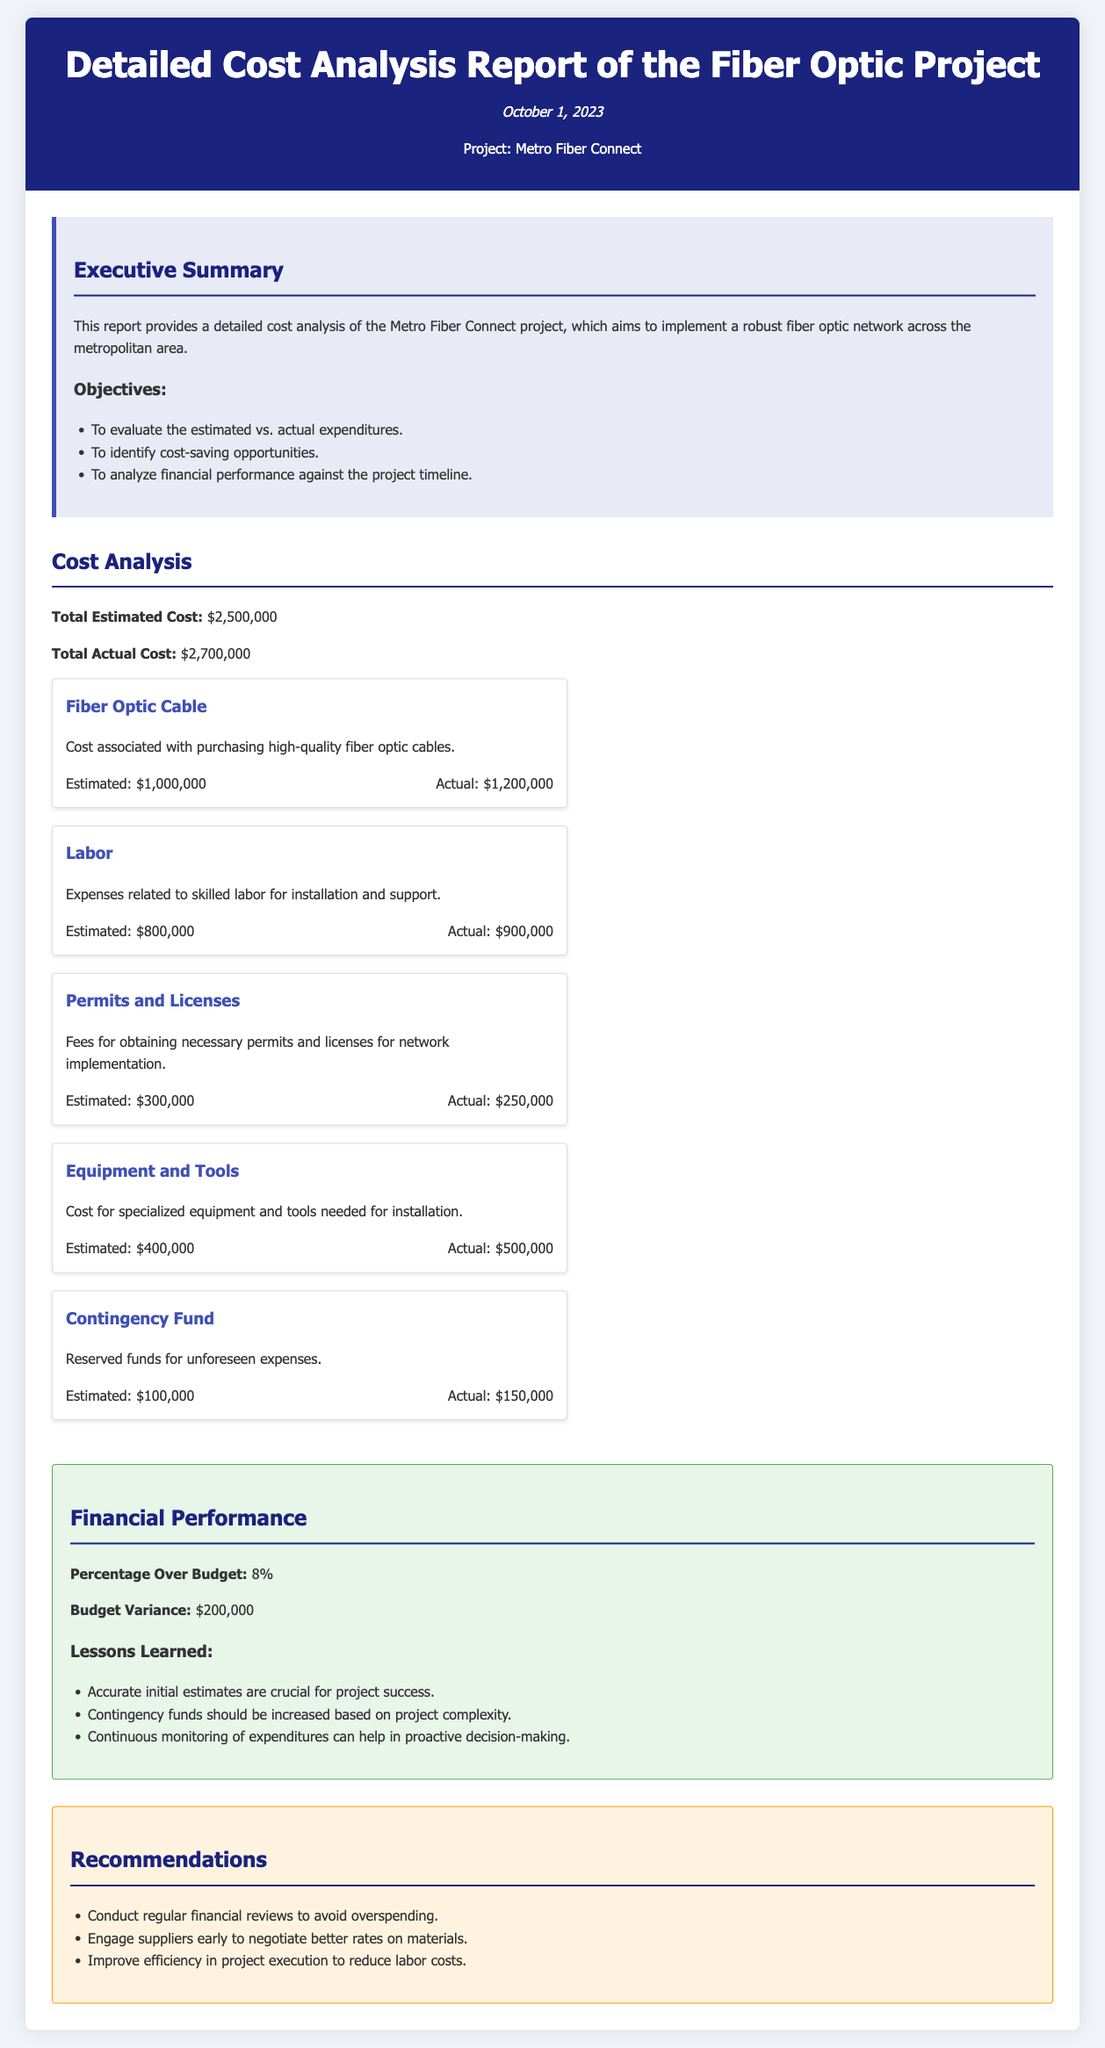What is the total estimated cost? The total estimated cost is provided in the document, which is $2,500,000.
Answer: $2,500,000 What is the total actual cost? The total actual cost is mentioned in the report, which is $2,700,000.
Answer: $2,700,000 What is the percentage over budget? The percentage over budget is calculated based on actual costs exceeding estimated costs, which is 8%.
Answer: 8% How much was spent on labor? The actual expenditure on labor is detailed in the cost breakdown, which is $900,000.
Answer: $900,000 What is the estimated cost for permits and licenses? The estimated cost for permits and licenses is listed in the cost breakdown as $300,000.
Answer: $300,000 Which category had the highest actual expenditure? By comparing the actual costs in the cost breakdown, Fiber Optic Cable had the highest actual expenditure.
Answer: Fiber Optic Cable What are the lessons learned mentioned in the report? The lessons learned include three specific points explained in the document.
Answer: Accurate initial estimates, increase contingency funds, continuous expenditure monitoring What is one recommendation made in the report? The recommendations include strategies for improved cost management, one of which is conducting regular financial reviews.
Answer: Conduct regular financial reviews 